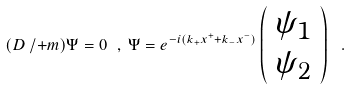<formula> <loc_0><loc_0><loc_500><loc_500>( D \, / + m ) \Psi = 0 \ , \, \Psi = e ^ { - i ( k _ { + } x ^ { + } + k _ { - } x ^ { - } ) } \left ( \begin{array} { l } { { \psi _ { 1 } } } \\ { { \psi _ { 2 } } } \end{array} \right ) \ .</formula> 